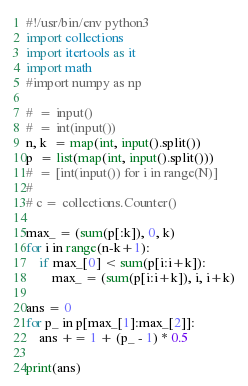Convert code to text. <code><loc_0><loc_0><loc_500><loc_500><_Python_>#!/usr/bin/env python3
import collections
import itertools as it
import math
#import numpy as np
 
#  = input()
#  = int(input())
n, k  = map(int, input().split())
p  = list(map(int, input().split()))
#  = [int(input()) for i in range(N)]
#
# c = collections.Counter()

max_ = (sum(p[:k]), 0, k)
for i in range(n-k+1):
    if max_[0] < sum(p[i:i+k]):
        max_ = (sum(p[i:i+k]), i, i+k)

ans = 0
for p_ in p[max_[1]:max_[2]]:
    ans += 1 + (p_ - 1) * 0.5

print(ans)
</code> 